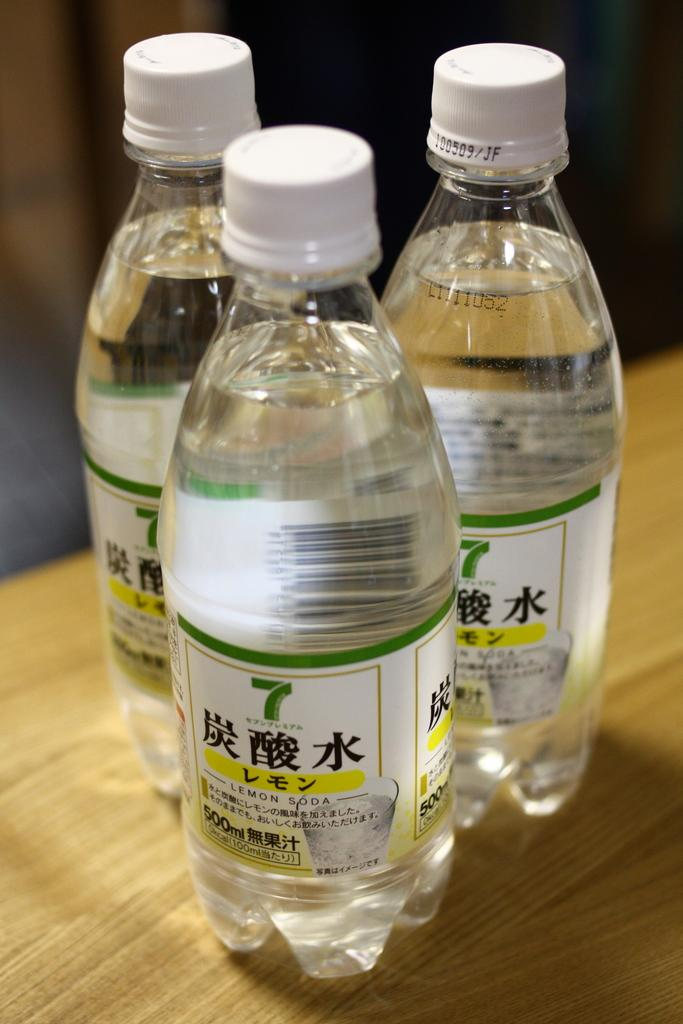How many water bottles are visible in the image? There are three water bottles in the image. Where are the water bottles located? The water bottles are on a table. What type of thread is being used by the queen in the image? There is no queen or thread present in the image; it only features three water bottles on a table. 